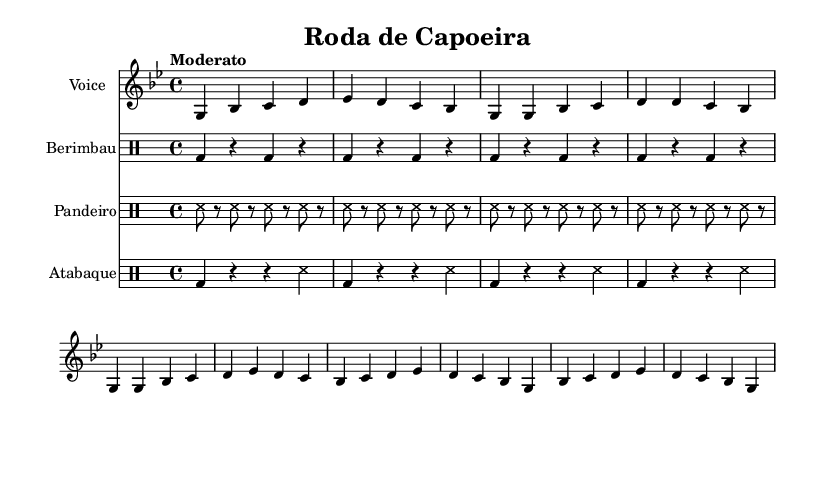What is the key signature of this music? The key signature is G minor, which has two flats (B flat and E flat). You can identify this by examining the key signature section on the left side of the sheet music.
Answer: G minor What is the time signature of this piece? The time signature is 4/4, meaning there are four beats in each measure, and a quarter note receives one beat. This can be found near the beginning of the sheet music next to the clef.
Answer: 4/4 What is the tempo marking for this piece? The tempo marking is "Moderato," which indicates a moderate pace. This is located at the beginning of the score under the global settings.
Answer: Moderato How many measures are in the voice part? The voice part contains sixteen measures in total. You can count the groupings of vertical lines between the notes to determine the number of measures.
Answer: 16 What instruments are included in this composition? The instruments included are Voice, Berimbau, Pandeiro, and Atabaque. Each part is labeled clearly at the beginning of its respective staff.
Answer: Voice, Berimbau, Pandeiro, Atabaque What are the lyrics of the chorus? The lyrics of the chorus are "Ê, capoeira / Ê, camarada." This is found beneath the chorus section of the voice part, where the lyrics are aligned with the music notes.
Answer: Ê, capoeira / Ê, camarada 